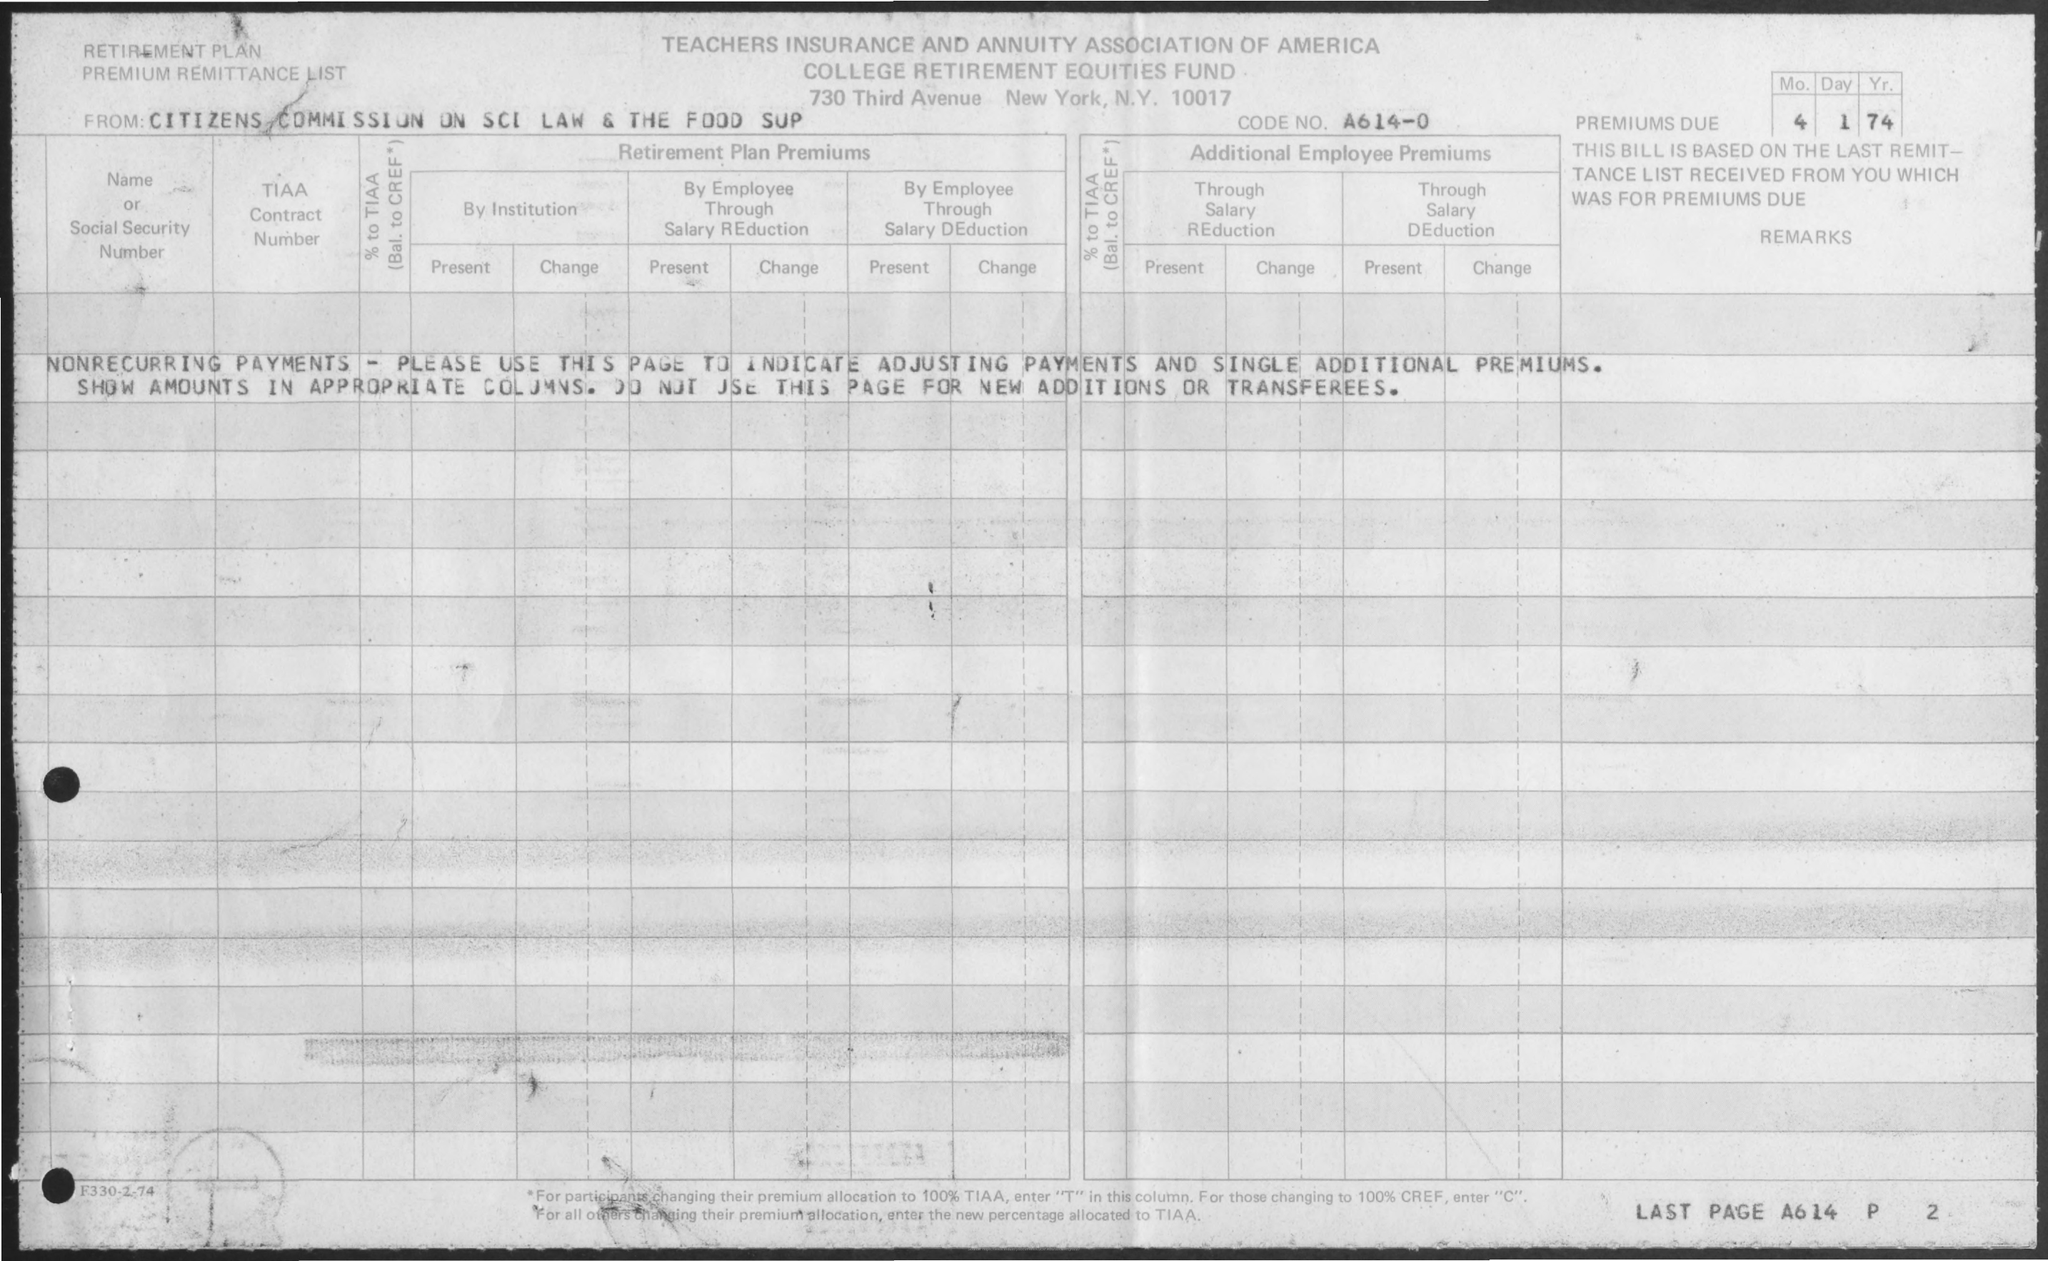What is the Code No.? The Code No. listed on the Teachers Insurance and Annuity Association of America document is A614-0. This number is likely used to identify a specific account or policy related to retirement plan premium remittances, as indicated by the heading of the form. 